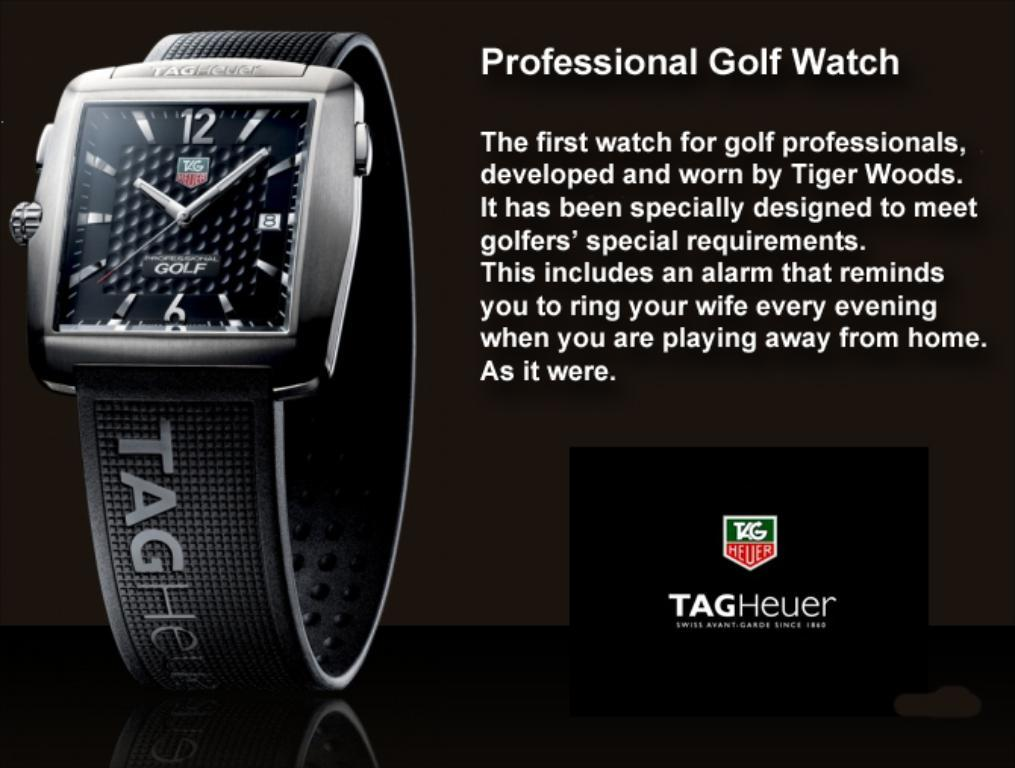<image>
Summarize the visual content of the image. An ad for a professional golf watch says it is worn by Tiger Woods. 